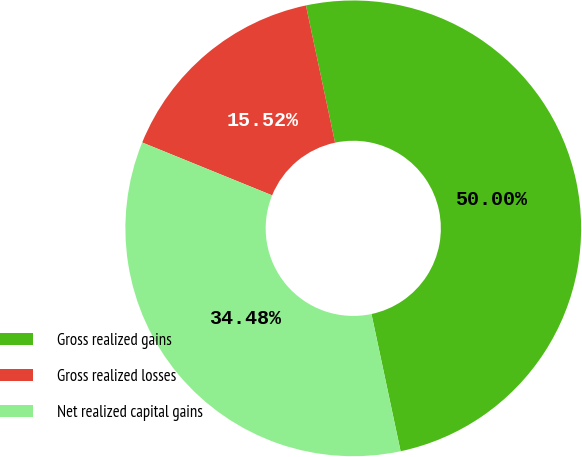Convert chart to OTSL. <chart><loc_0><loc_0><loc_500><loc_500><pie_chart><fcel>Gross realized gains<fcel>Gross realized losses<fcel>Net realized capital gains<nl><fcel>50.0%<fcel>15.52%<fcel>34.48%<nl></chart> 